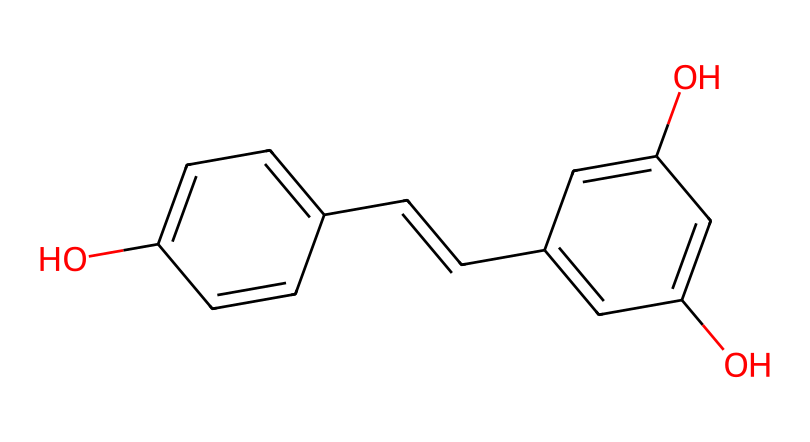What is the chemical name for the structure represented by the SMILES? The SMILES representation corresponds to a molecule with the chemical name resveratrol. This can be identified by analyzing the structure's distinctive features, including its hydroxyl groups and conjugated double bonds.
Answer: resveratrol How many hydroxyl (–OH) groups are present in resveratrol? By examining the structure depicted in the SMILES, we observe there are three –OH groups attached to phenolic rings in the compound. Count the hydroxyl functionalities to find their number.
Answer: three What is the primary functional group present in resveratrol? The primary functional group in this molecule can be identified by looking for groups that define the chemical's reactivity—here, the hydroxyl groups (–OH) represent the functional groups, indicating its antioxidant properties.
Answer: hydroxyl What type of compound is resveratrol? Resveratrol is classified as a polyphenol, which is a specific type of antioxidant compound often found in plants, characterized by multiple phenolic units within its structure. This can be determined by its structural features and the presence of aromatic rings.
Answer: polyphenol How many aromatic rings are there in resveratrol? From the SMILES structure, we can see two distinct aromatic rings in the molecule, which can be validated by identifying the cyclic structures with alternating double bonds that meet the criteria for aromaticity.
Answer: two Is resveratrol a natural or synthetic compound? Resveratrol is a natural compound commonly found in the skin of red grapes and other fruits. This is established by its occurrence in dietary sources and documentation of its bioactivity in plants, indicating its natural origin.
Answer: natural What is one potential health benefit associated with resveratrol? Resveratrol is known for its antioxidant properties, which can provide various health benefits, particularly in promoting cardiovascular health. This is based on research studies linking its intake to a reduction in oxidative stress and inflammation.
Answer: antioxidant properties 